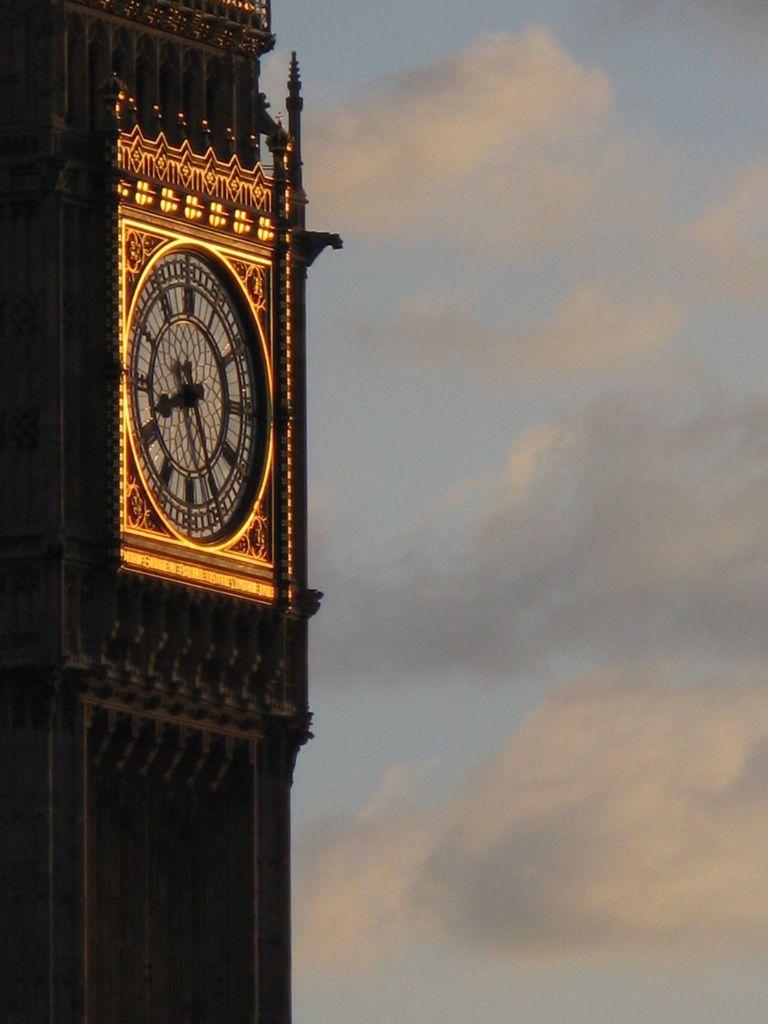Can you describe this image briefly? In the center of the image we can see the sky, clouds, one clock tower and a few other objects. And we can see some art work on the tower. 